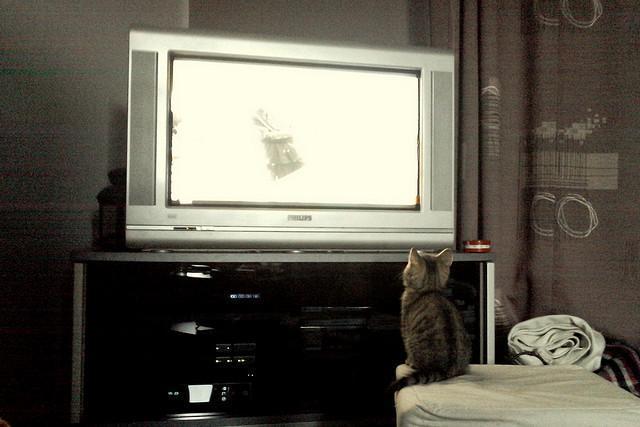How many beds are in the photo?
Give a very brief answer. 1. 